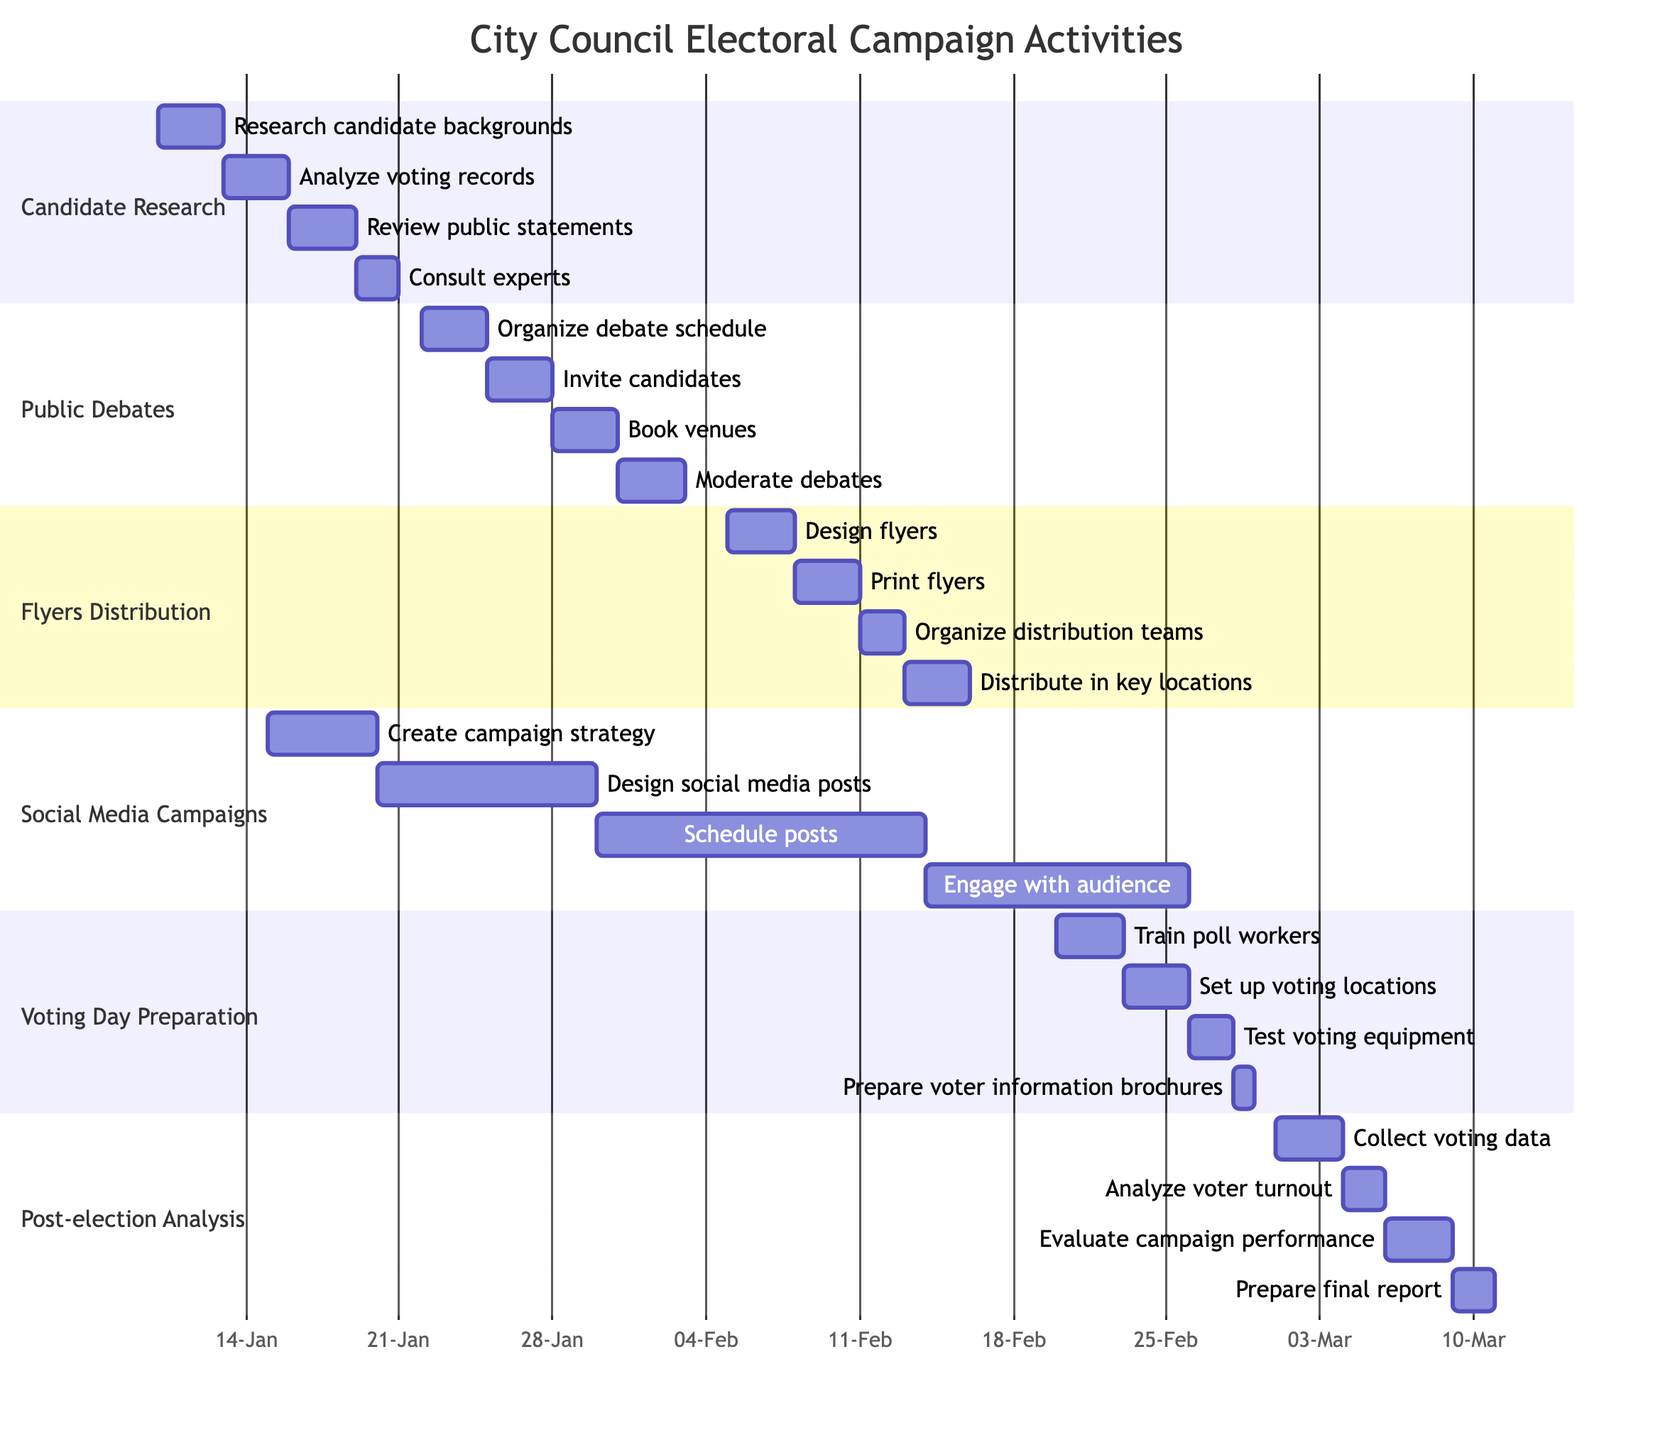What is the duration of the Candidate Research phase? The Candidate Research phase starts on January 10, 2024, and ends on January 20, 2024, which gives it a duration of 10 days.
Answer: 10 days Which activity starts on the same date as "Design flyers"? "Design flyers" starts on February 5, 2024. The only activity that starts on this date is "Flyers Distribution," hence it is the relevant section for this activity.
Answer: Flyers Distribution How many activities are planned in the Social Media Campaigns section? Looking at the Gantt chart, the Social Media Campaigns section comprises four distinct activities: Create campaign strategy, Design social media posts, Schedule posts, and Engage with audience. Hence, the number of activities is four.
Answer: 4 What is the end date of the Voting Day Preparation section? The end date for the Voting Day Preparation activities is February 28, 2024. This can be validated by checking the last activity in that section, which is "Prepare voter information brochures."
Answer: February 28, 2024 Which two activities overlap in the timeline from January 15 to February 02? "Social Media Campaigns" starts on January 15 and runs until February 25, while "Public Debates" starts on January 22 and ends on February 02. Therefore, both activities overlap in this timeline.
Answer: Social Media Campaigns, Public Debates Which activity immediately follows the "Invite candidates" task? The "Invite candidates" task starts on January 25, 2024, and is followed directly by the "Book venues" task, which starts on January 28, 2024. Hence, this is the immediate successor task.
Answer: Book venues How long does it take to complete the Post-election Analysis? The Post-election Analysis phase starts on March 1, 2024, and ends on March 10, 2024. This duration is calculated by counting the days from the starting date to the ending date, which totals to 10 days.
Answer: 10 days Which section contains the activity "Test voting equipment"? The activity "Test voting equipment" is part of the Voting Day Preparation section, as it is listed under that specific section of the Gantt chart.
Answer: Voting Day Preparation 